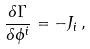<formula> <loc_0><loc_0><loc_500><loc_500>\frac { \delta \Gamma } { \delta \phi ^ { i } } = - J _ { i } \, ,</formula> 